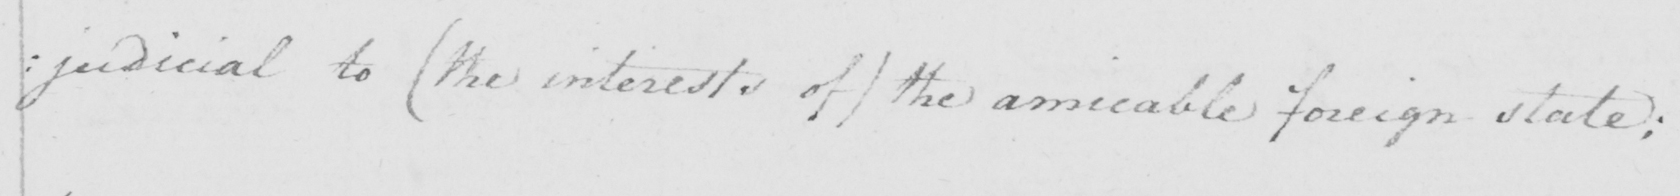What text is written in this handwritten line? to  ( the interests of )  the amicable foreign state : 